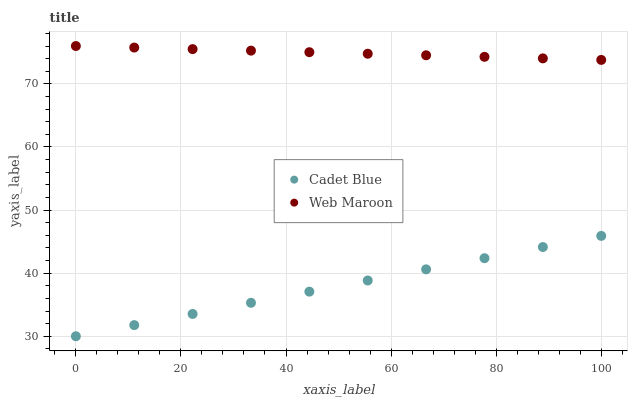Does Cadet Blue have the minimum area under the curve?
Answer yes or no. Yes. Does Web Maroon have the maximum area under the curve?
Answer yes or no. Yes. Does Web Maroon have the minimum area under the curve?
Answer yes or no. No. Is Cadet Blue the smoothest?
Answer yes or no. Yes. Is Web Maroon the roughest?
Answer yes or no. Yes. Is Web Maroon the smoothest?
Answer yes or no. No. Does Cadet Blue have the lowest value?
Answer yes or no. Yes. Does Web Maroon have the lowest value?
Answer yes or no. No. Does Web Maroon have the highest value?
Answer yes or no. Yes. Is Cadet Blue less than Web Maroon?
Answer yes or no. Yes. Is Web Maroon greater than Cadet Blue?
Answer yes or no. Yes. Does Cadet Blue intersect Web Maroon?
Answer yes or no. No. 